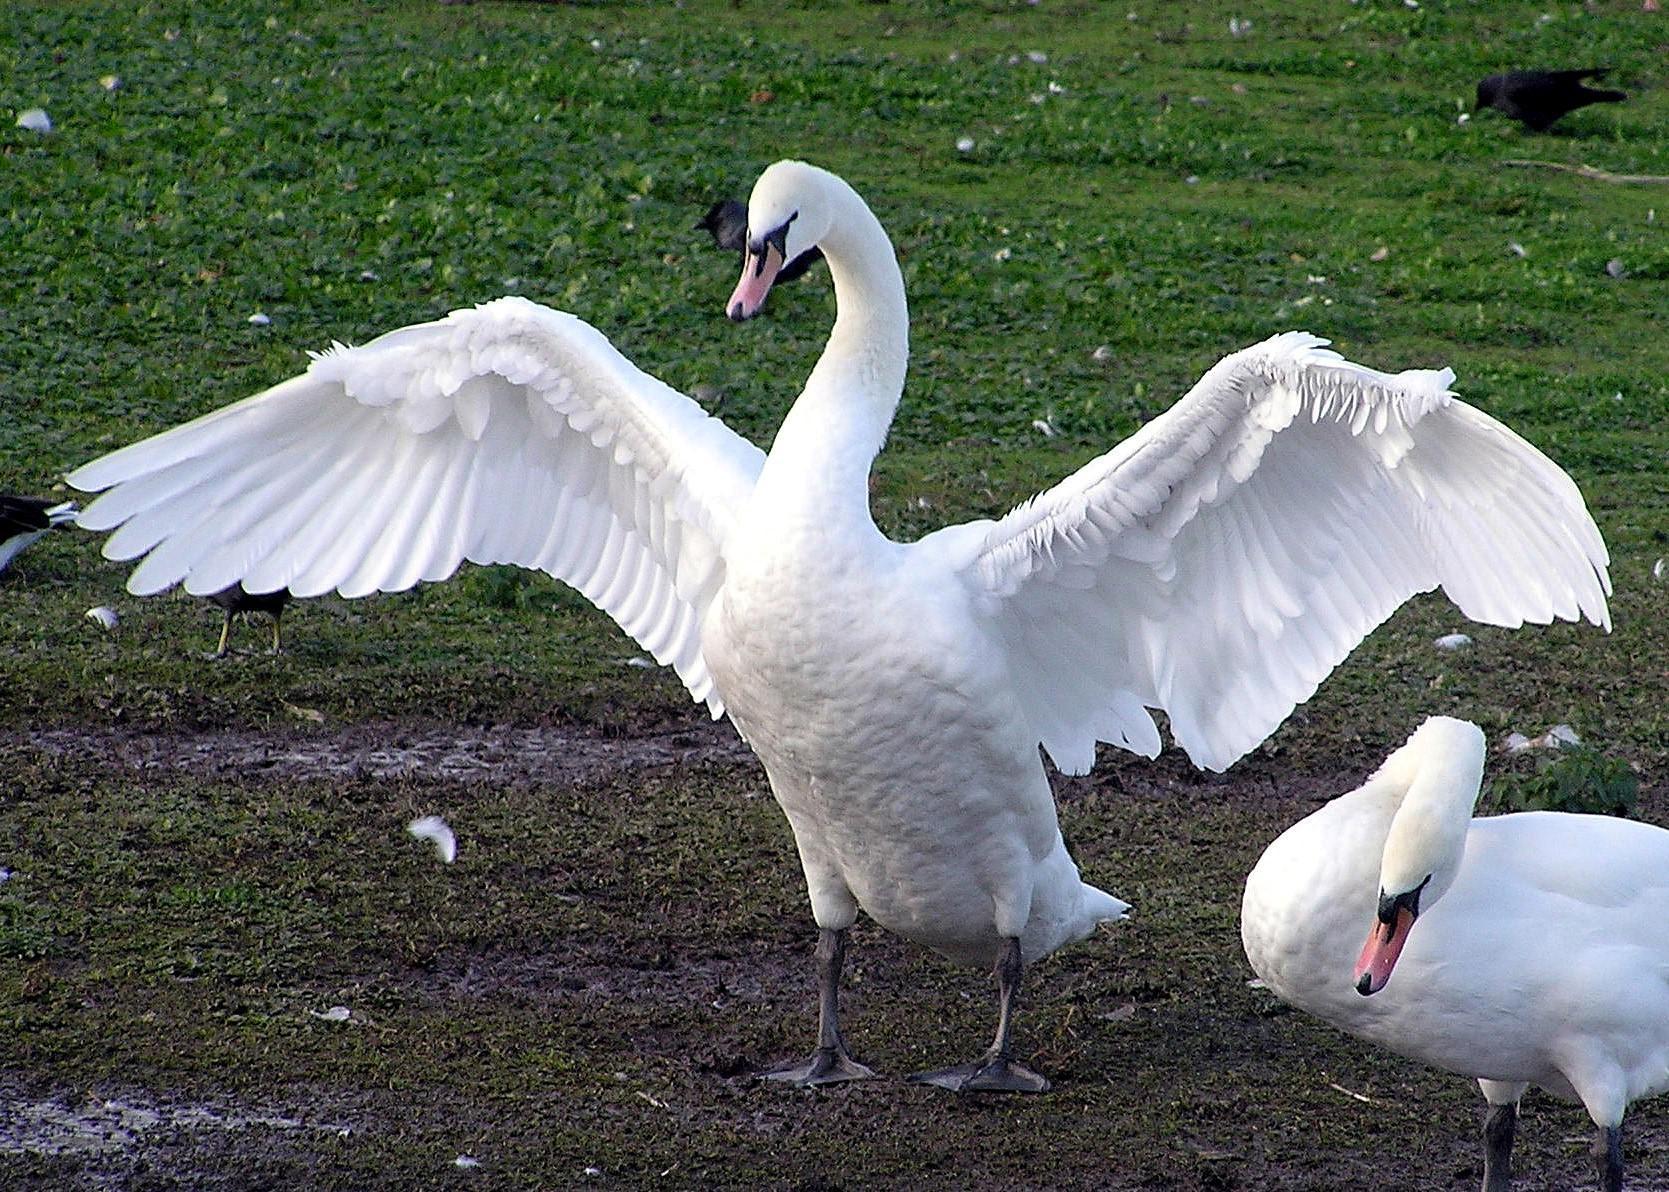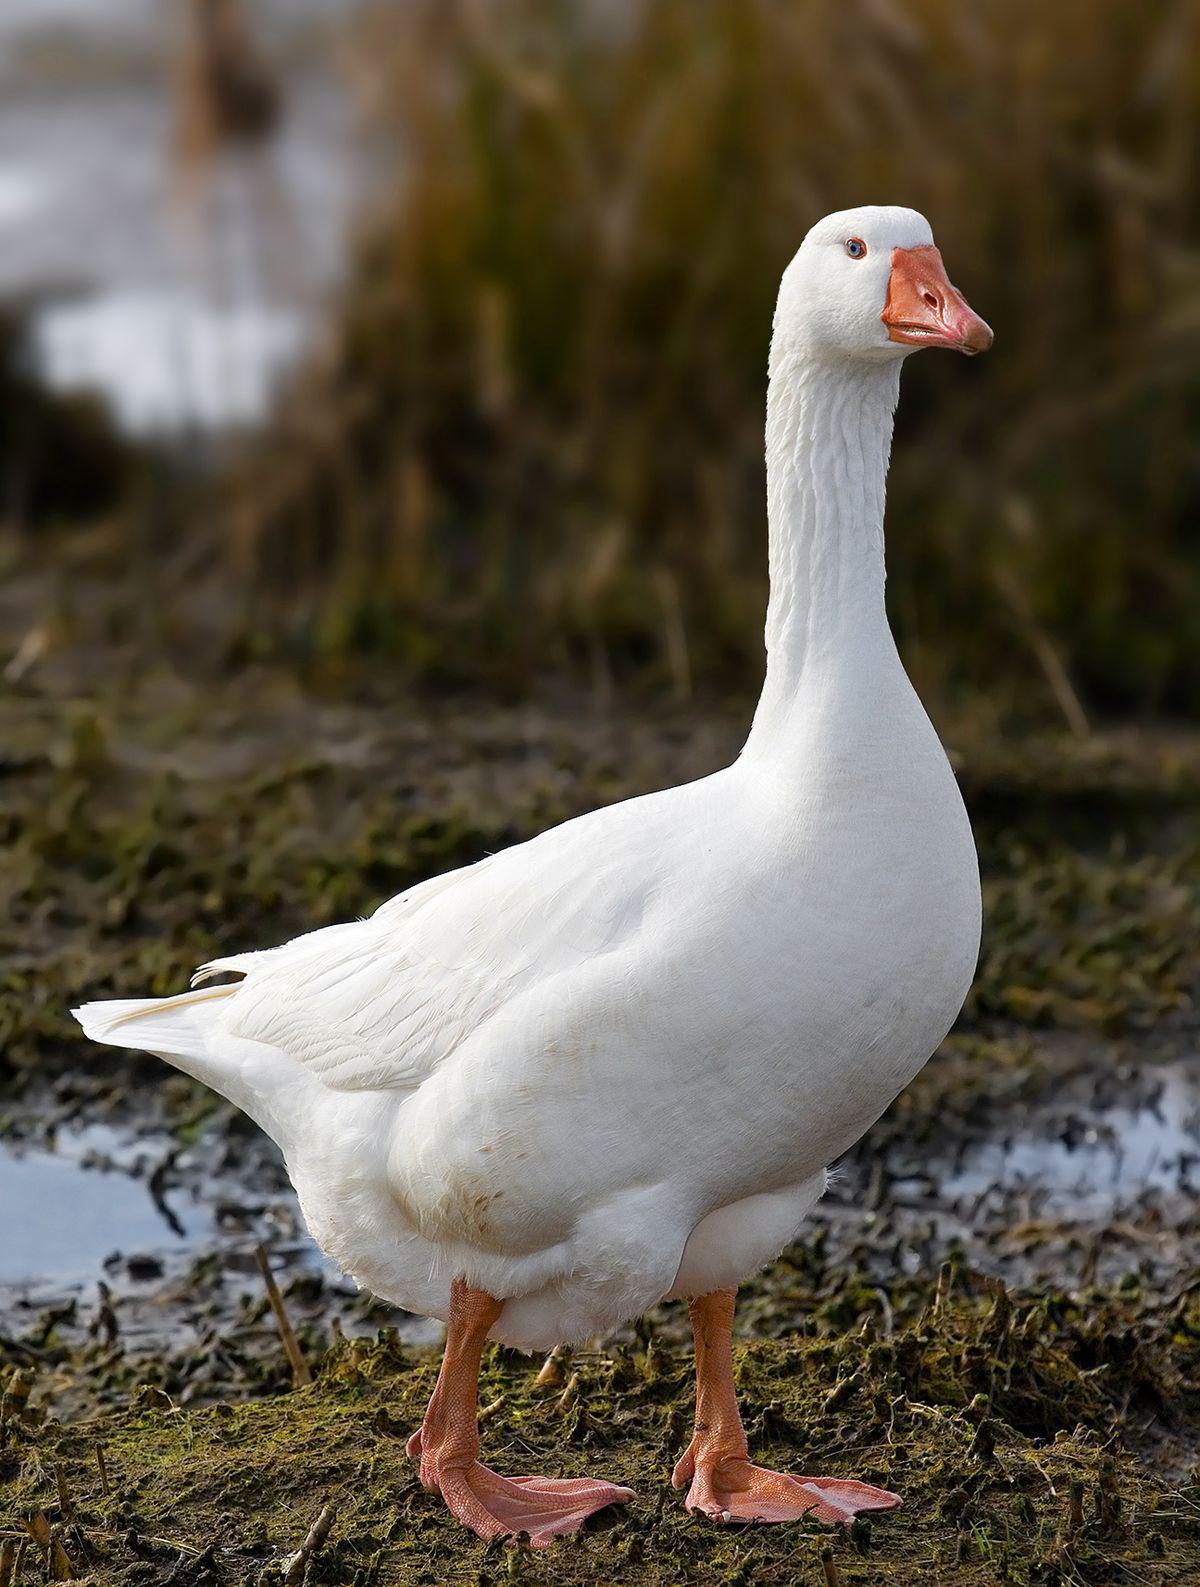The first image is the image on the left, the second image is the image on the right. Examine the images to the left and right. Is the description "There are at least two animals in every image." accurate? Answer yes or no. No. 